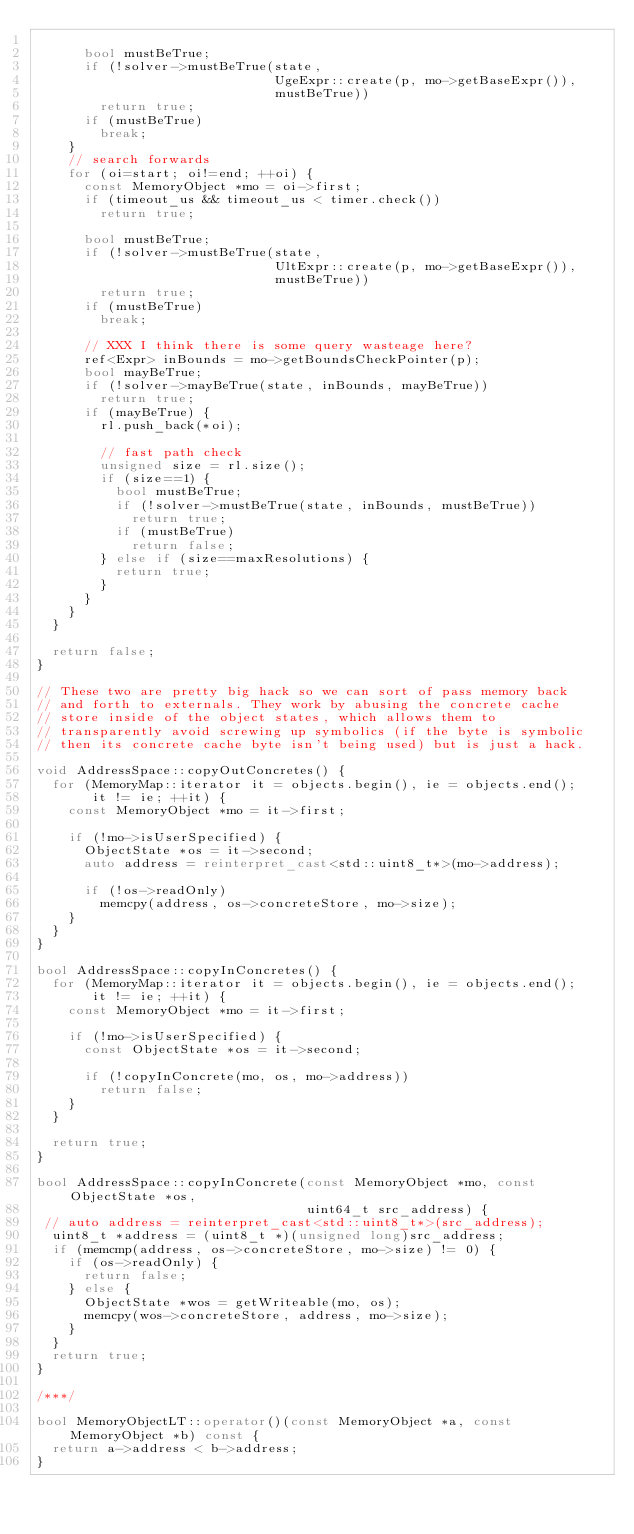<code> <loc_0><loc_0><loc_500><loc_500><_C++_>        
      bool mustBeTrue;
      if (!solver->mustBeTrue(state, 
                              UgeExpr::create(p, mo->getBaseExpr()),
                              mustBeTrue))
        return true;
      if (mustBeTrue)
        break;
    }
    // search forwards
    for (oi=start; oi!=end; ++oi) {
      const MemoryObject *mo = oi->first;
      if (timeout_us && timeout_us < timer.check())
        return true;

      bool mustBeTrue;
      if (!solver->mustBeTrue(state, 
                              UltExpr::create(p, mo->getBaseExpr()),
                              mustBeTrue))
        return true;
      if (mustBeTrue)
        break;
      
      // XXX I think there is some query wasteage here?
      ref<Expr> inBounds = mo->getBoundsCheckPointer(p);
      bool mayBeTrue;
      if (!solver->mayBeTrue(state, inBounds, mayBeTrue))
        return true;
      if (mayBeTrue) {
        rl.push_back(*oi);
        
        // fast path check
        unsigned size = rl.size();
        if (size==1) {
          bool mustBeTrue;
          if (!solver->mustBeTrue(state, inBounds, mustBeTrue))
            return true;
          if (mustBeTrue)
            return false;
        } else if (size==maxResolutions) {
          return true;
        }
      }
    }
  }

  return false;
}

// These two are pretty big hack so we can sort of pass memory back
// and forth to externals. They work by abusing the concrete cache
// store inside of the object states, which allows them to
// transparently avoid screwing up symbolics (if the byte is symbolic
// then its concrete cache byte isn't being used) but is just a hack.

void AddressSpace::copyOutConcretes() {
  for (MemoryMap::iterator it = objects.begin(), ie = objects.end(); 
       it != ie; ++it) {
    const MemoryObject *mo = it->first;

    if (!mo->isUserSpecified) {
      ObjectState *os = it->second;
      auto address = reinterpret_cast<std::uint8_t*>(mo->address);

      if (!os->readOnly)
        memcpy(address, os->concreteStore, mo->size);
    }
  }
}

bool AddressSpace::copyInConcretes() {
  for (MemoryMap::iterator it = objects.begin(), ie = objects.end(); 
       it != ie; ++it) {
    const MemoryObject *mo = it->first;

    if (!mo->isUserSpecified) {
      const ObjectState *os = it->second;

      if (!copyInConcrete(mo, os, mo->address))
        return false;
    }
  }

  return true;
}

bool AddressSpace::copyInConcrete(const MemoryObject *mo, const ObjectState *os,
                                  uint64_t src_address) {
 // auto address = reinterpret_cast<std::uint8_t*>(src_address);
  uint8_t *address = (uint8_t *)(unsigned long)src_address;
  if (memcmp(address, os->concreteStore, mo->size) != 0) {
    if (os->readOnly) {
      return false;
    } else {
      ObjectState *wos = getWriteable(mo, os);
      memcpy(wos->concreteStore, address, mo->size);
    }
  }
  return true;
}

/***/

bool MemoryObjectLT::operator()(const MemoryObject *a, const MemoryObject *b) const {
  return a->address < b->address;
}

</code> 